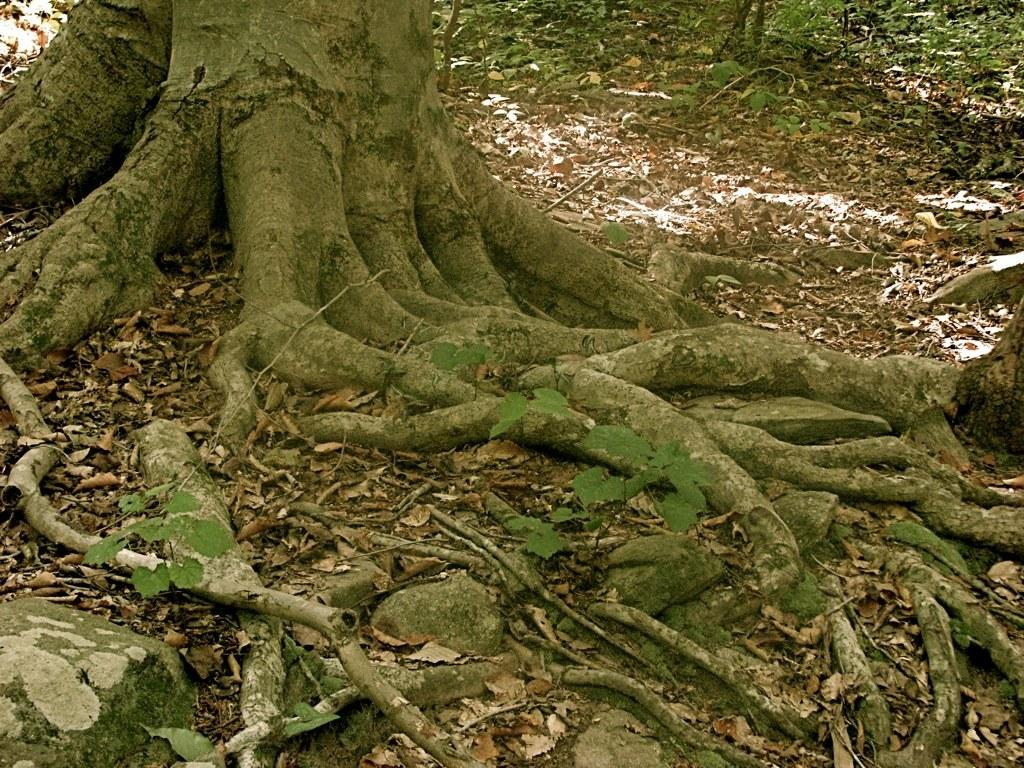What is the main subject of the image? The main subject of the image is a tree trunk. What can be observed about the tree trunk? The tree trunk has roots. What other objects are present in the image? Stones and dried leaves on the ground are present in the image. What can be seen in the background of the image? There are plants in the background of the image. What type of bed can be seen in the image? There are no beds present in the image; it features a tree trunk with roots, stones, dried leaves, and plants in the background. 